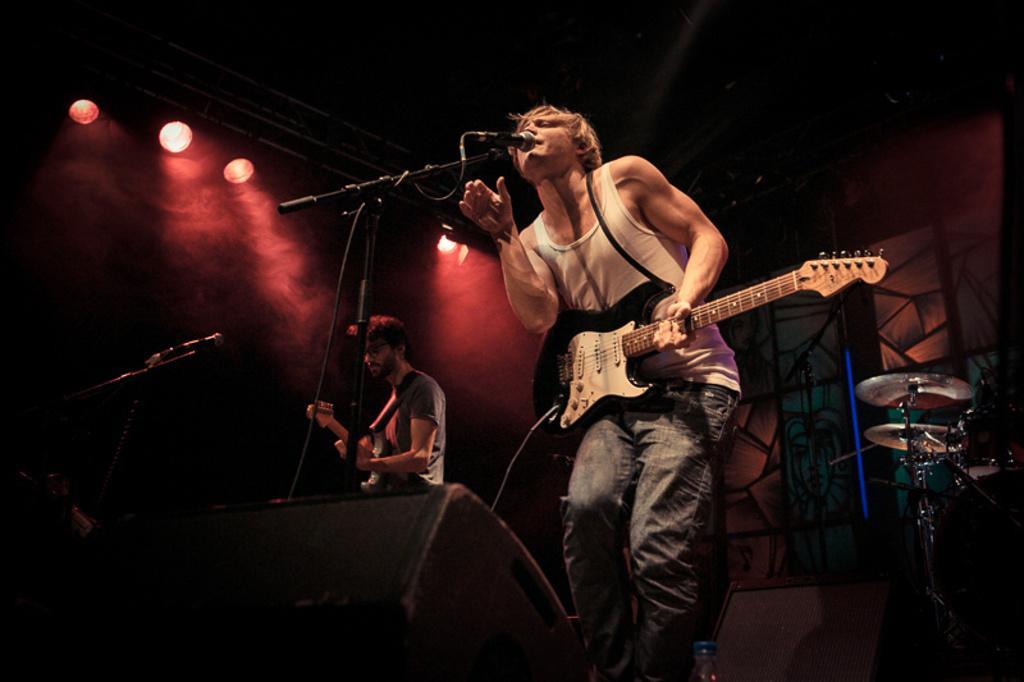Describe this image in one or two sentences. In the middle of the image a man is standing and playing guitar and singing. Behind him a man is playing guitar. Bottom right side of the image there is a musical instrument. Bottom left side of the image there is a microphone. Top left side of the image there are some lights. 